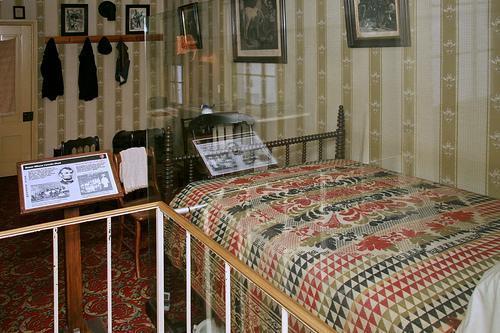How many chairs are there?
Give a very brief answer. 2. 